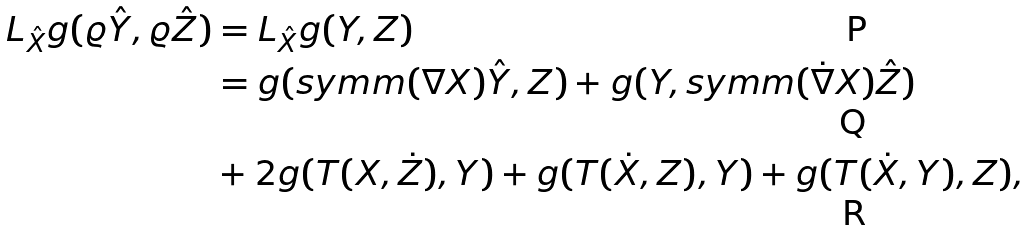Convert formula to latex. <formula><loc_0><loc_0><loc_500><loc_500>L _ { \hat { X } } g ( \varrho \hat { Y } , \varrho \hat { Z } ) & = L _ { \hat { X } } g ( Y , Z ) \\ & = g ( s y m m ( \nabla X ) \hat { Y } , Z ) + g ( Y , s y m m ( \dot { \nabla } X ) \hat { Z } ) \\ & + 2 g ( T ( X , \dot { Z } ) , Y ) + g ( T ( \dot { X } , Z ) , Y ) + g ( T ( \dot { X } , Y ) , Z ) ,</formula> 